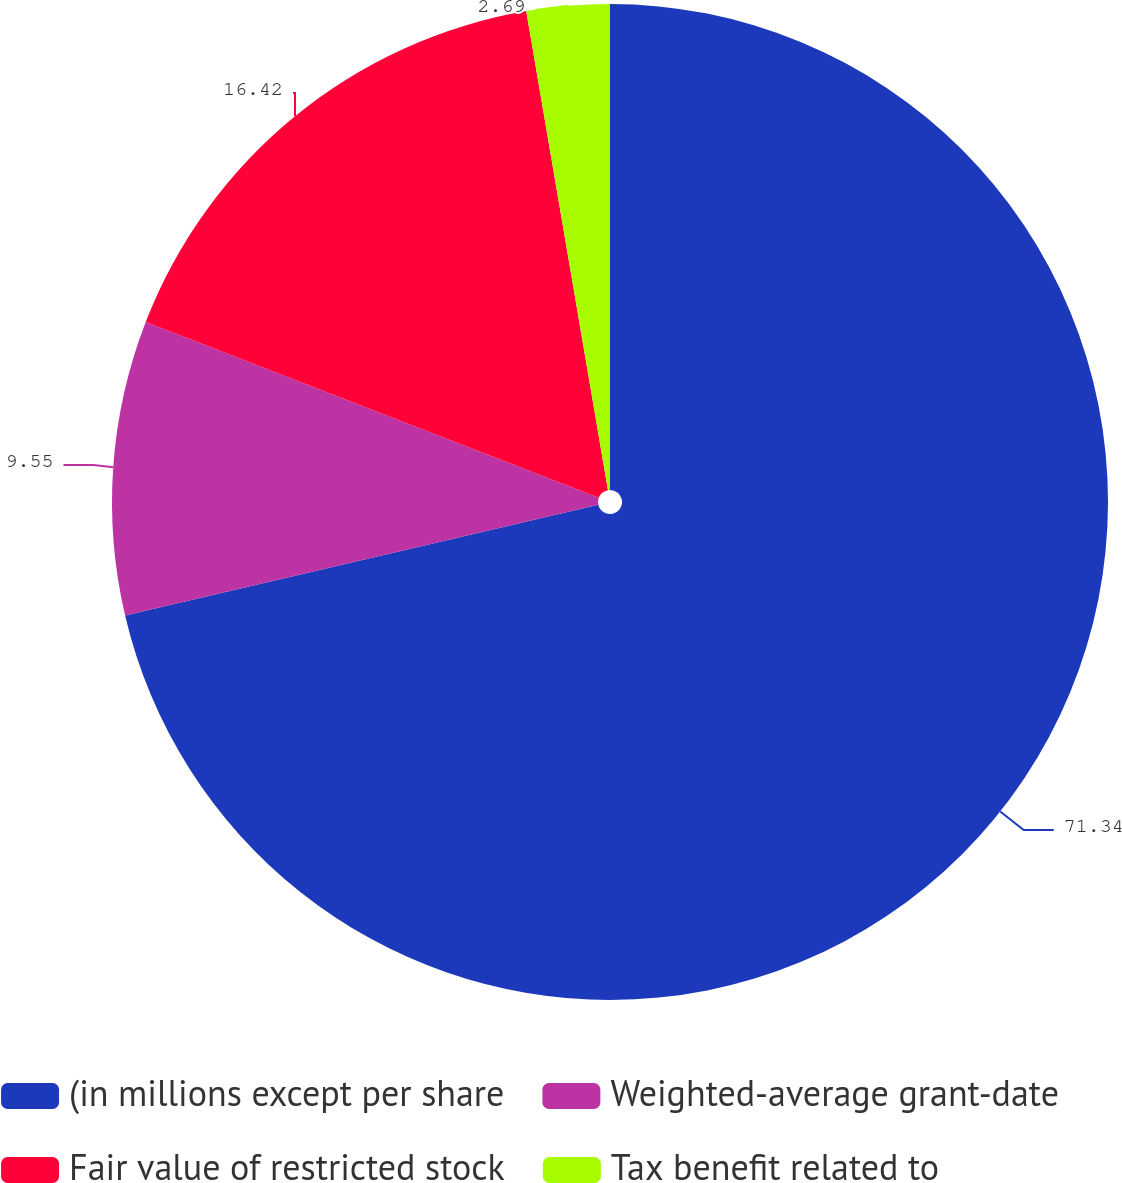Convert chart. <chart><loc_0><loc_0><loc_500><loc_500><pie_chart><fcel>(in millions except per share<fcel>Weighted-average grant-date<fcel>Fair value of restricted stock<fcel>Tax benefit related to<nl><fcel>71.34%<fcel>9.55%<fcel>16.42%<fcel>2.69%<nl></chart> 